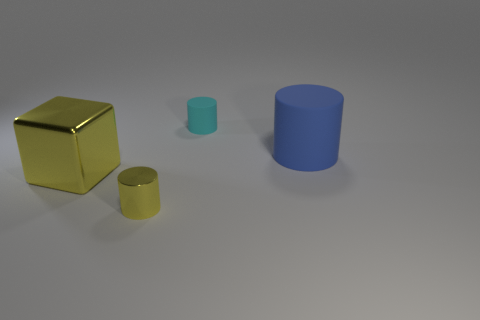What textures are visible on the objects? The objects have a matte finish with subtle lighting reflections, suggesting a non-glossy surface texture. 